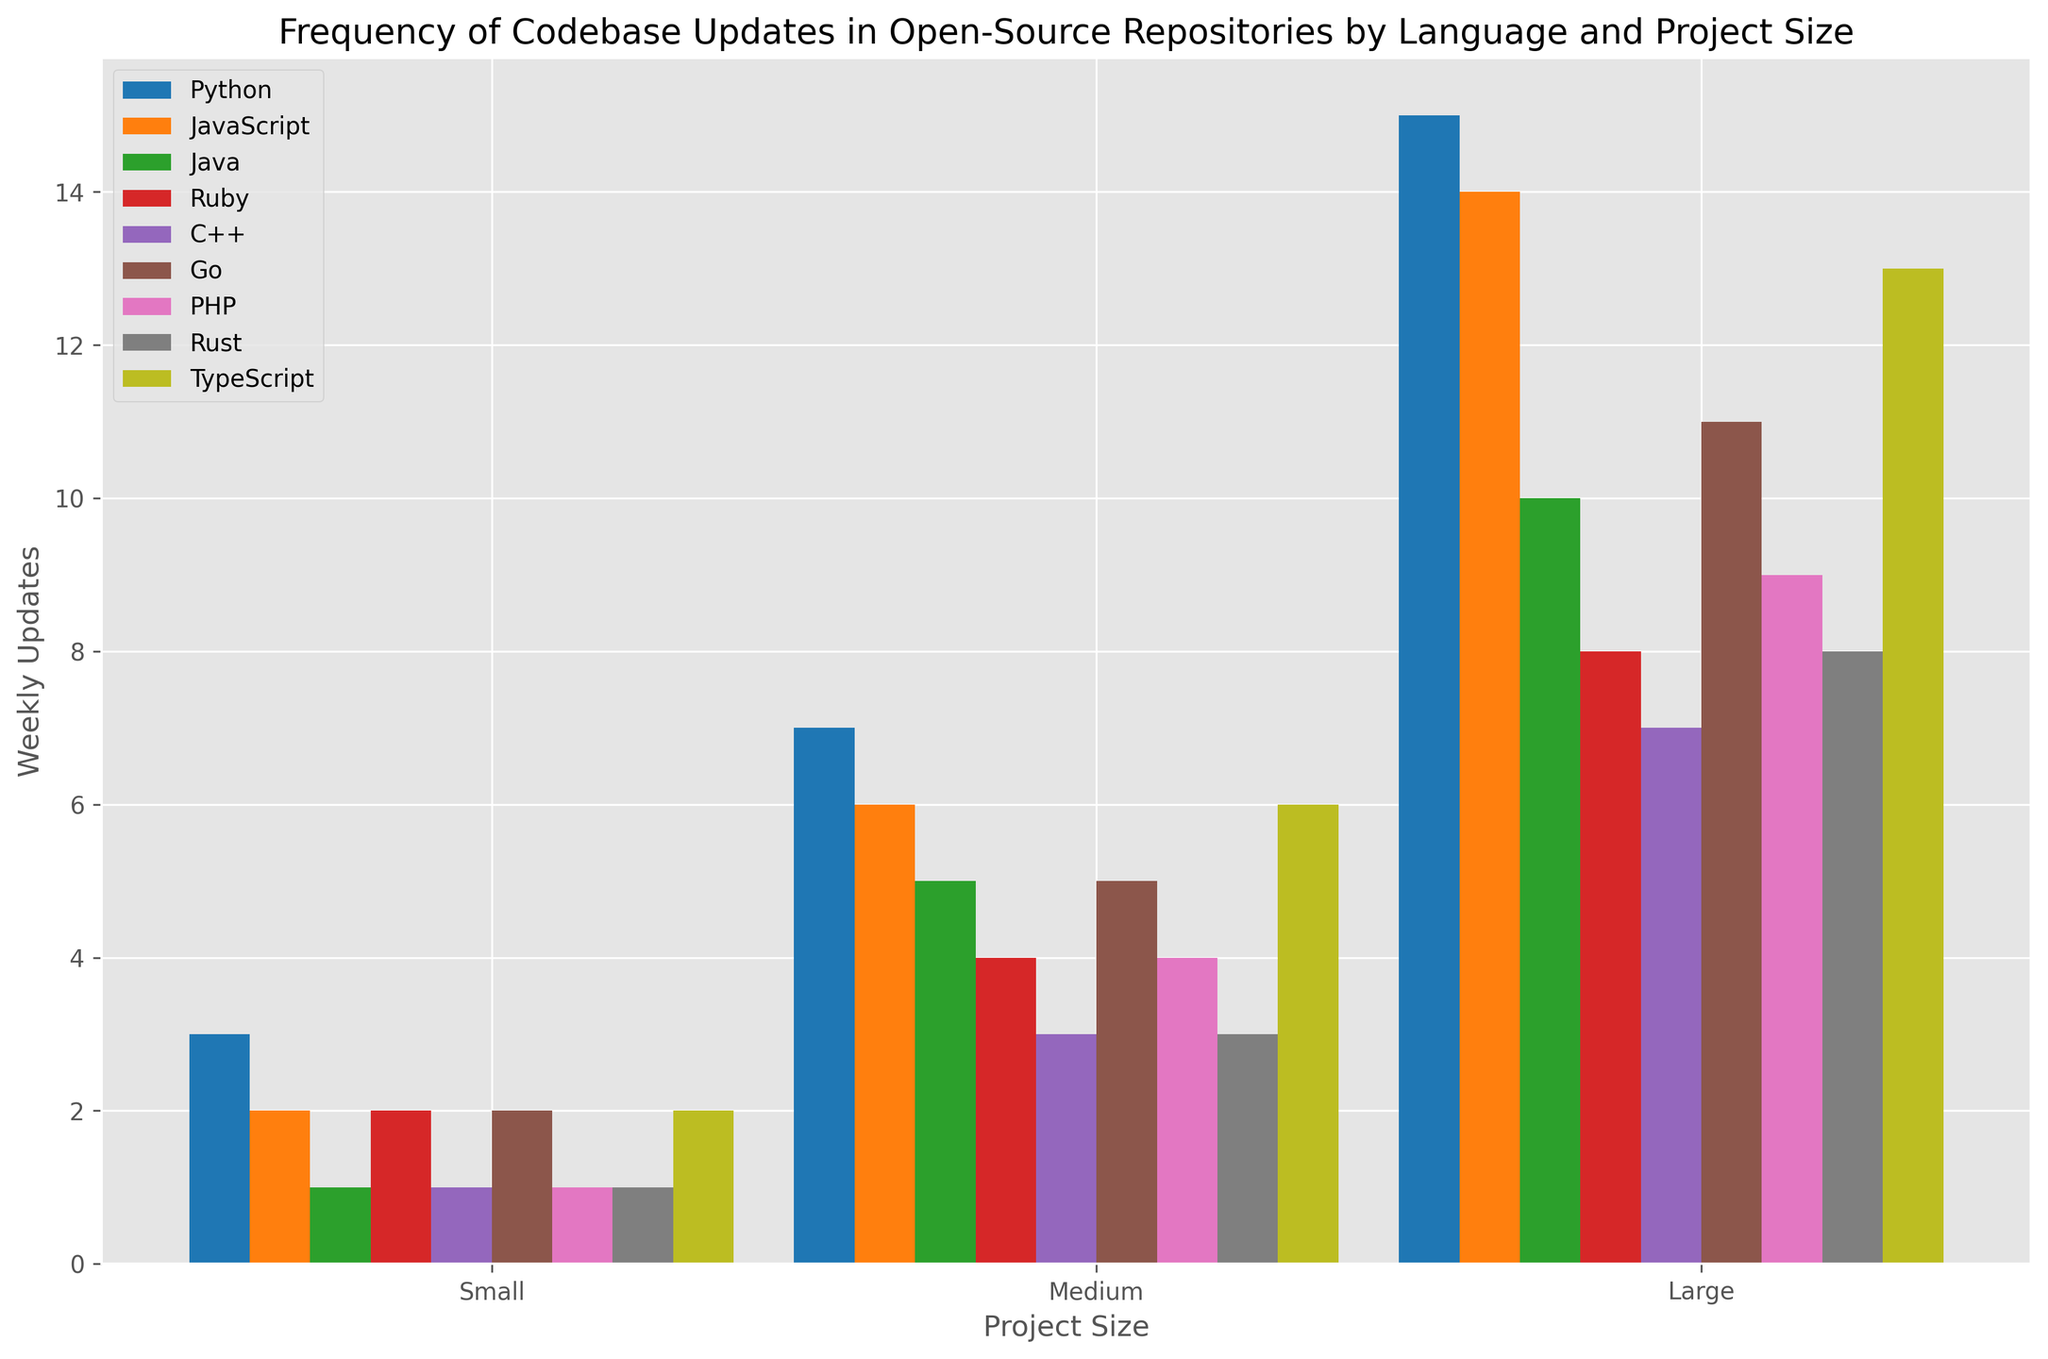What language has the highest number of weekly updates for large projects? Look at the bars corresponding to large projects and identify which is the tallest. Python has the highest bar height for large projects indicating the highest number of weekly updates.
Answer: Python Which project size shows the smallest difference in weekly updates between Python and Java? Examine the bars for Python and Java within each project size (small, medium, large). Calculate the difference in weekly updates for each size: Small (3-1=2), Medium (7-5=2), and Large (15-10=5). The smallest difference is for small and medium projects, both of which have a difference of 2.
Answer: Small and Medium How do the weekly updates for medium-sized PHP projects compare to large TypeScript projects? Identify the bar representing medium-sized PHP projects and large TypeScript projects. The height of the PHP medium bar is 4, and the height of the TypeScript large bar is 13.
Answer: TypeScript large projects have more updates What is the average number of weekly updates for medium-sized projects in all languages? Sum the updates for medium-sized projects across all languages and divide by the number of languages. (7+6+5+4+3+5+4+3+6)/9 = 43/9 = 4.78
Answer: 4.78 Which language has the least frequent updates for small-sized projects? Look at the bars corresponding to small projects and identify the shortest bar. Java and C++ both have the shortest bar, indicating the least frequent updates.
Answer: Java and C++ Compare the weekly updates for large Go projects with large PHP projects. Which one is higher? Identify the bars for large Go projects and large PHP projects. The height of the Go large bar is 11, whereas the height of the PHP large bar is 9.
Answer: Go is higher Are medium-sized Ruby projects updated more frequently than medium-sized C++ projects? Look at the bars for medium-sized Ruby and C++ projects. Ruby has a bar height of 4, while C++ has a bar height of 3.
Answer: Yes What is the total number of weekly updates for all small-sized projects combined? Sum the updates for small-sized projects across all languages: 3+2+1+2+1+2+1+1+2 = 15
Answer: 15 Which language has more weekly updates for medium-sized projects, Rust or Go? Compare the heights of the bars for medium-sized Rust and Go projects. Rust has a bar height of 3, and Go has a bar height of 5.
Answer: Go What is the difference in weekly updates between medium-sized Python and large JavaScript projects? Check the bar heights for medium-sized Python and large JavaScript projects. Medium Python is 7, and large JavaScript is 14. The difference is 14 - 7 = 7.
Answer: 7 